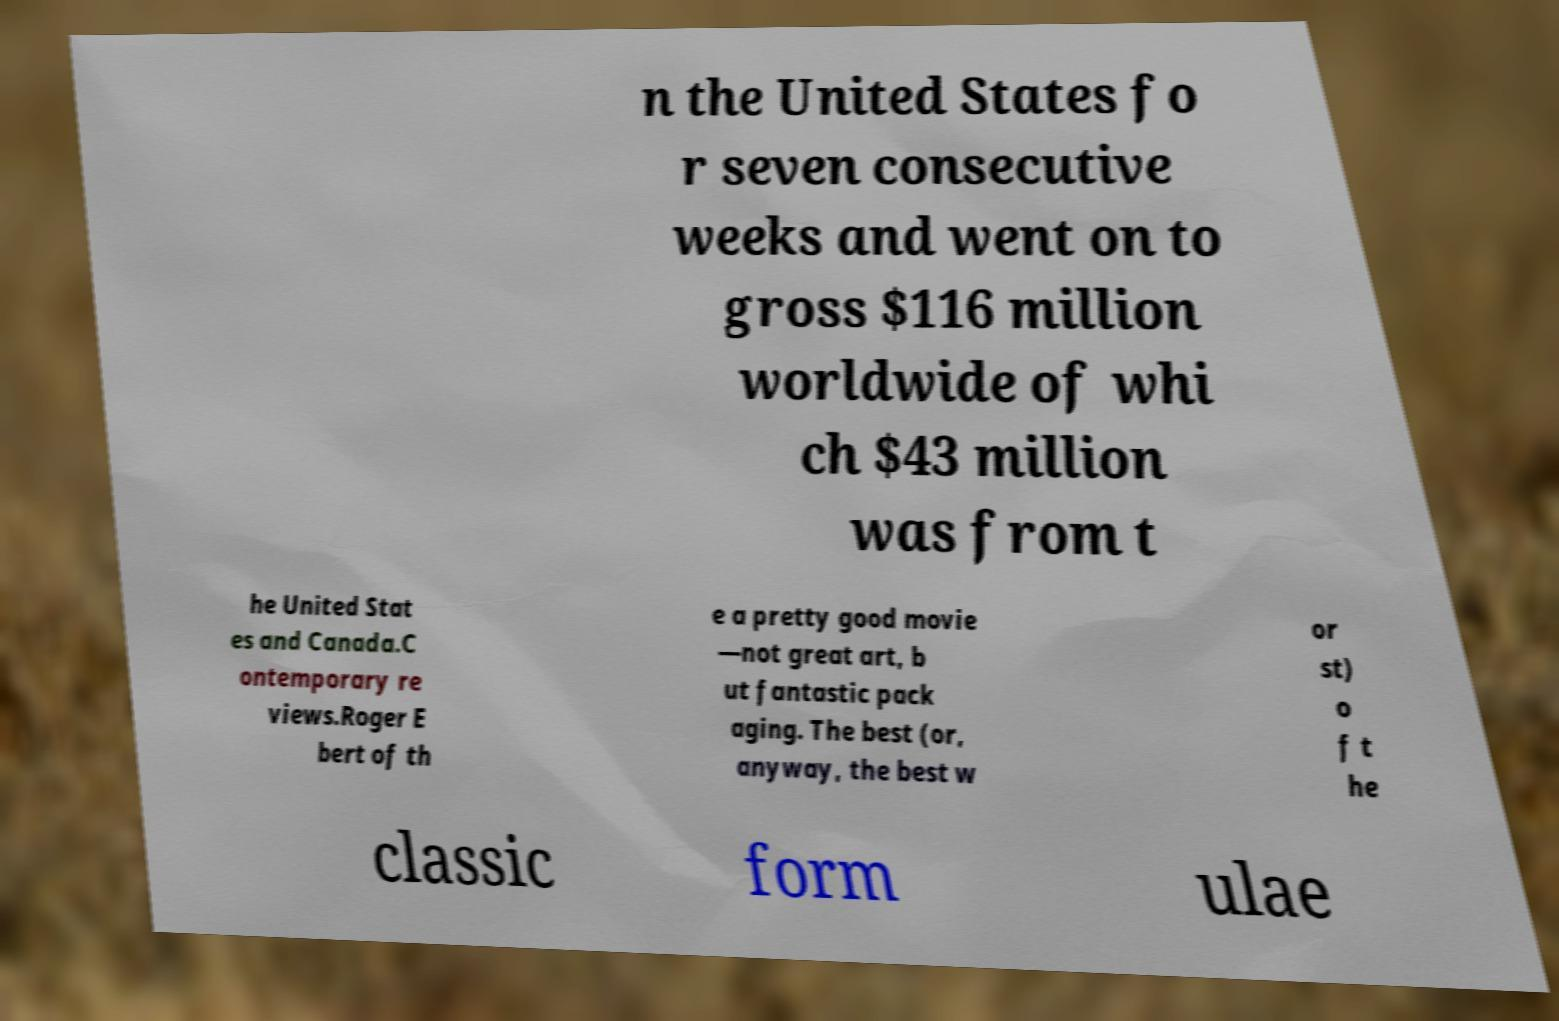Could you extract and type out the text from this image? n the United States fo r seven consecutive weeks and went on to gross $116 million worldwide of whi ch $43 million was from t he United Stat es and Canada.C ontemporary re views.Roger E bert of th e a pretty good movie —not great art, b ut fantastic pack aging. The best (or, anyway, the best w or st) o f t he classic form ulae 